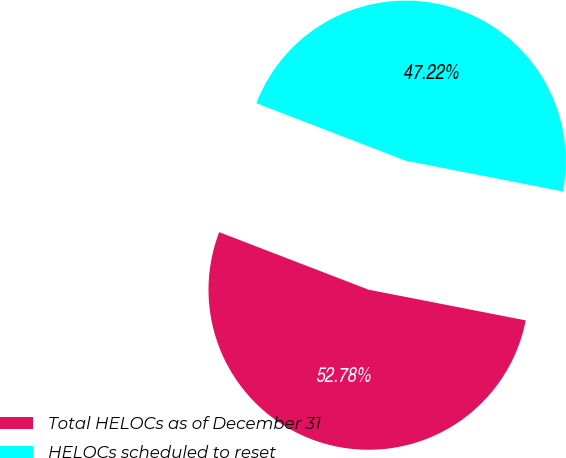Convert chart to OTSL. <chart><loc_0><loc_0><loc_500><loc_500><pie_chart><fcel>Total HELOCs as of December 31<fcel>HELOCs scheduled to reset<nl><fcel>52.78%<fcel>47.22%<nl></chart> 